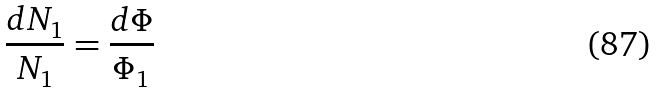<formula> <loc_0><loc_0><loc_500><loc_500>\frac { d N _ { 1 } } { N _ { 1 } } = \frac { d \Phi } { \Phi _ { 1 } }</formula> 